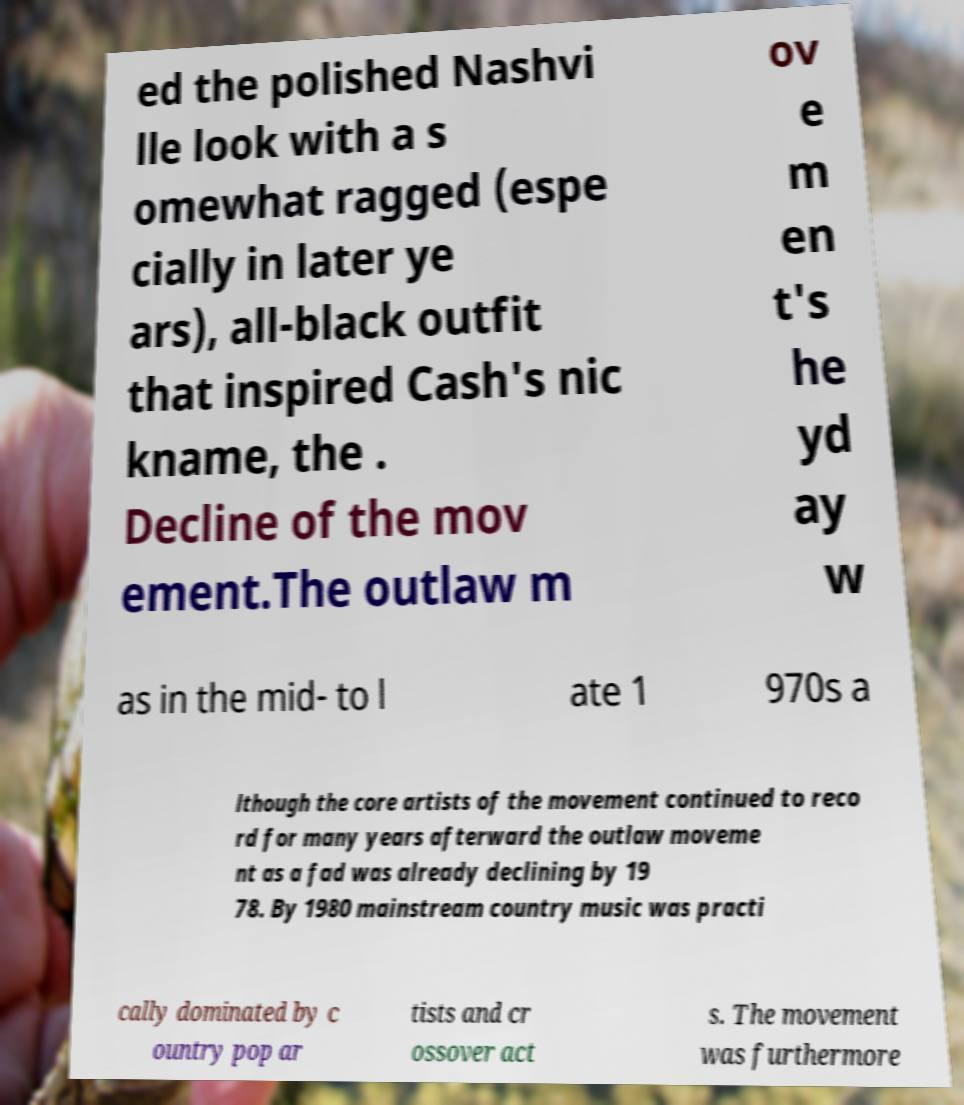Can you accurately transcribe the text from the provided image for me? ed the polished Nashvi lle look with a s omewhat ragged (espe cially in later ye ars), all-black outfit that inspired Cash's nic kname, the . Decline of the mov ement.The outlaw m ov e m en t's he yd ay w as in the mid- to l ate 1 970s a lthough the core artists of the movement continued to reco rd for many years afterward the outlaw moveme nt as a fad was already declining by 19 78. By 1980 mainstream country music was practi cally dominated by c ountry pop ar tists and cr ossover act s. The movement was furthermore 